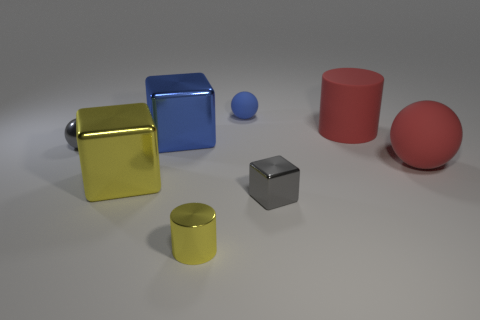Are there any tiny blue matte spheres?
Keep it short and to the point. Yes. Is the size of the rubber ball that is in front of the blue matte ball the same as the gray metal sphere?
Your answer should be very brief. No. Is the number of metallic cylinders less than the number of blue objects?
Your answer should be very brief. Yes. There is a small gray shiny thing left of the yellow thing in front of the tiny gray metal thing that is on the right side of the blue sphere; what is its shape?
Offer a terse response. Sphere. Are there any green cylinders that have the same material as the tiny gray sphere?
Offer a very short reply. No. There is a cylinder that is in front of the large red ball; is it the same color as the large block that is in front of the small gray sphere?
Give a very brief answer. Yes. Is the number of small blue rubber objects that are right of the small gray cube less than the number of gray rubber objects?
Provide a succinct answer. No. How many things are large red metal cubes or things behind the red matte cylinder?
Offer a terse response. 1. There is a big thing that is the same material as the big red sphere; what color is it?
Make the answer very short. Red. What number of things are either big yellow shiny things or large red matte objects?
Your response must be concise. 3. 